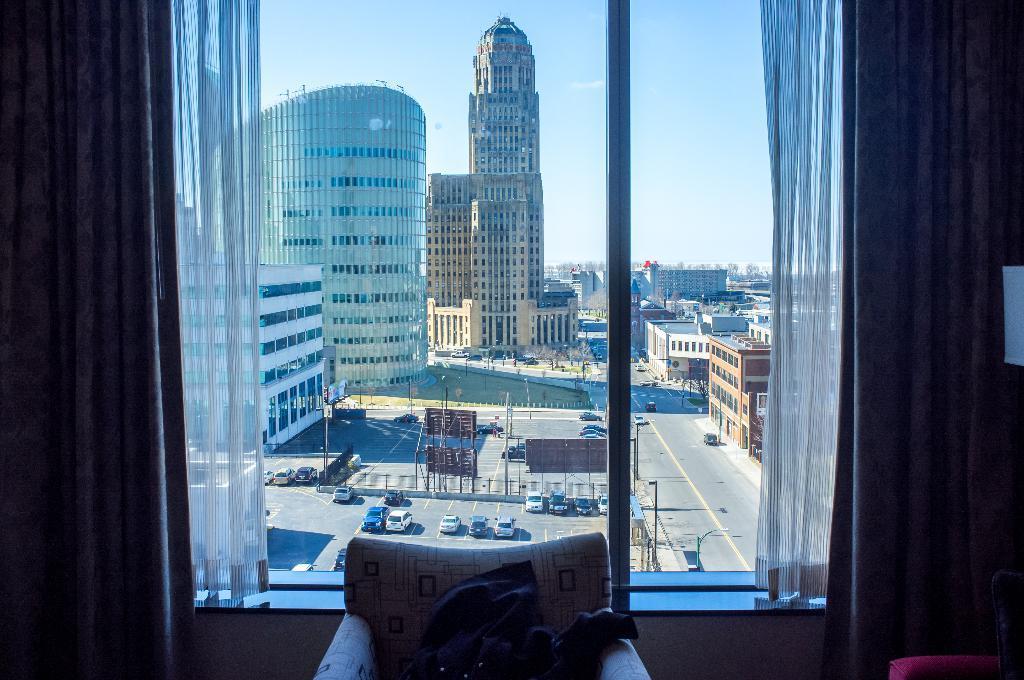Describe this image in one or two sentences. In this image, we can see a window contains curtains. There is a chair at the bottom of the image. There are some buildings and cars in the middle of the image. There is a sky at the top of the image. 